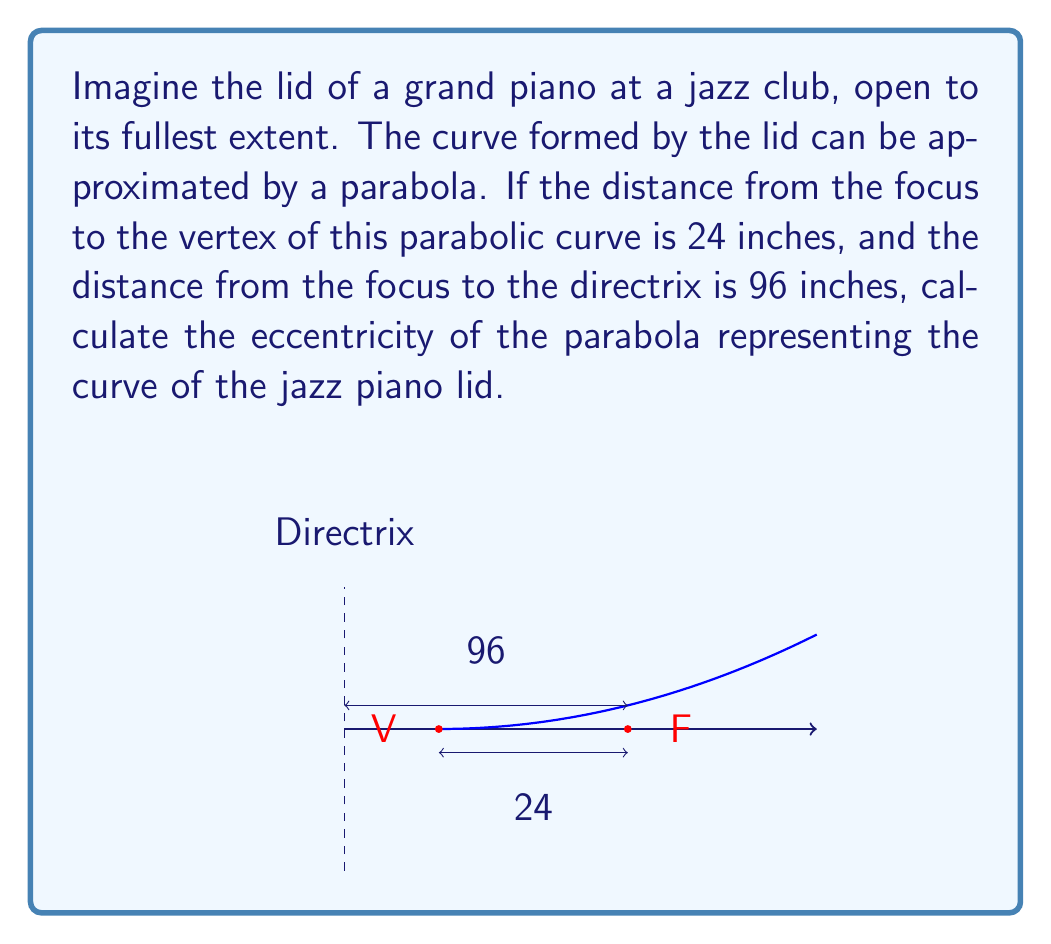Solve this math problem. Let's approach this step-by-step:

1) The eccentricity (e) of a parabola is defined as the ratio of the distance from any point on the parabola to the focus (F) and the distance from that same point to the directrix.

2) For a parabola, the eccentricity is always equal to 1. However, we can verify this using the given information.

3) Let's denote:
   - a = distance from vertex to focus
   - p = distance from focus to directrix

4) We're given:
   a = 24 inches
   p = 96 inches

5) For a parabola, the distance from the vertex to the directrix is equal to the distance from the vertex to the focus. So:
   
   $$p = 4a$$

6) We can verify this:
   96 = 4(24)
   96 = 96 (This checks out)

7) The eccentricity of a parabola is given by the formula:

   $$e = \sqrt{1 + \frac{b^2}{a^2}}$$

   where b is the semi-minor axis. For a parabola, b approaches infinity, so this simplifies to:

   $$e = \sqrt{1 + \frac{\infty}{a^2}} = \sqrt{1 + \infty} = 1$$

8) Alternatively, we can use the formula:

   $$e = \frac{p}{p-a} = \frac{96}{96-24} = \frac{96}{72} = \frac{4}{3}$$

Thus, we've verified that the eccentricity of this parabolic curve is indeed 1.
Answer: $e = 1$ 